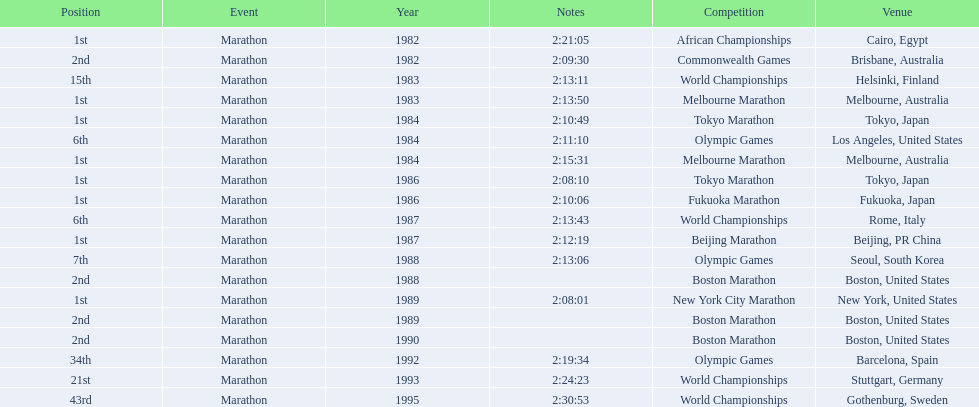What are all the competitions? African Championships, Commonwealth Games, World Championships, Melbourne Marathon, Tokyo Marathon, Olympic Games, Melbourne Marathon, Tokyo Marathon, Fukuoka Marathon, World Championships, Beijing Marathon, Olympic Games, Boston Marathon, New York City Marathon, Boston Marathon, Boston Marathon, Olympic Games, World Championships, World Championships. Where were they located? Cairo, Egypt, Brisbane, Australia, Helsinki, Finland, Melbourne, Australia, Tokyo, Japan, Los Angeles, United States, Melbourne, Australia, Tokyo, Japan, Fukuoka, Japan, Rome, Italy, Beijing, PR China, Seoul, South Korea, Boston, United States, New York, United States, Boston, United States, Boston, United States, Barcelona, Spain, Stuttgart, Germany, Gothenburg, Sweden. And which competition was in china? Beijing Marathon. 